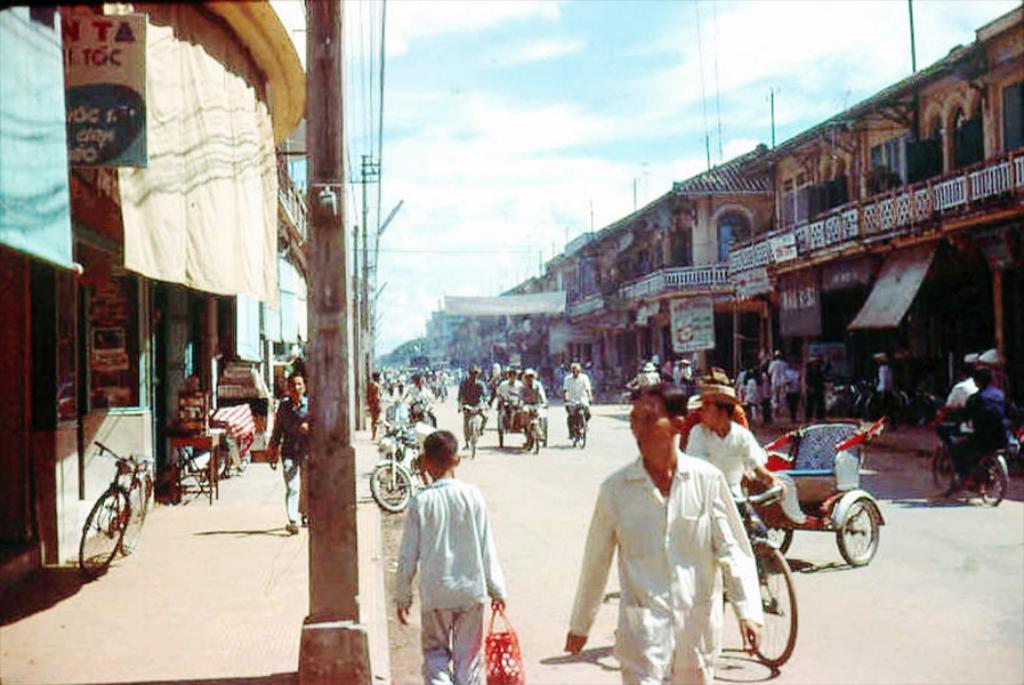In one or two sentences, can you explain what this image depicts? In this image it seems there is a road on which there are people riding cycle,rickshaw and few people are walking on the road. To the left side there are buildings,hoardings and banners. To the left side there is a store. 